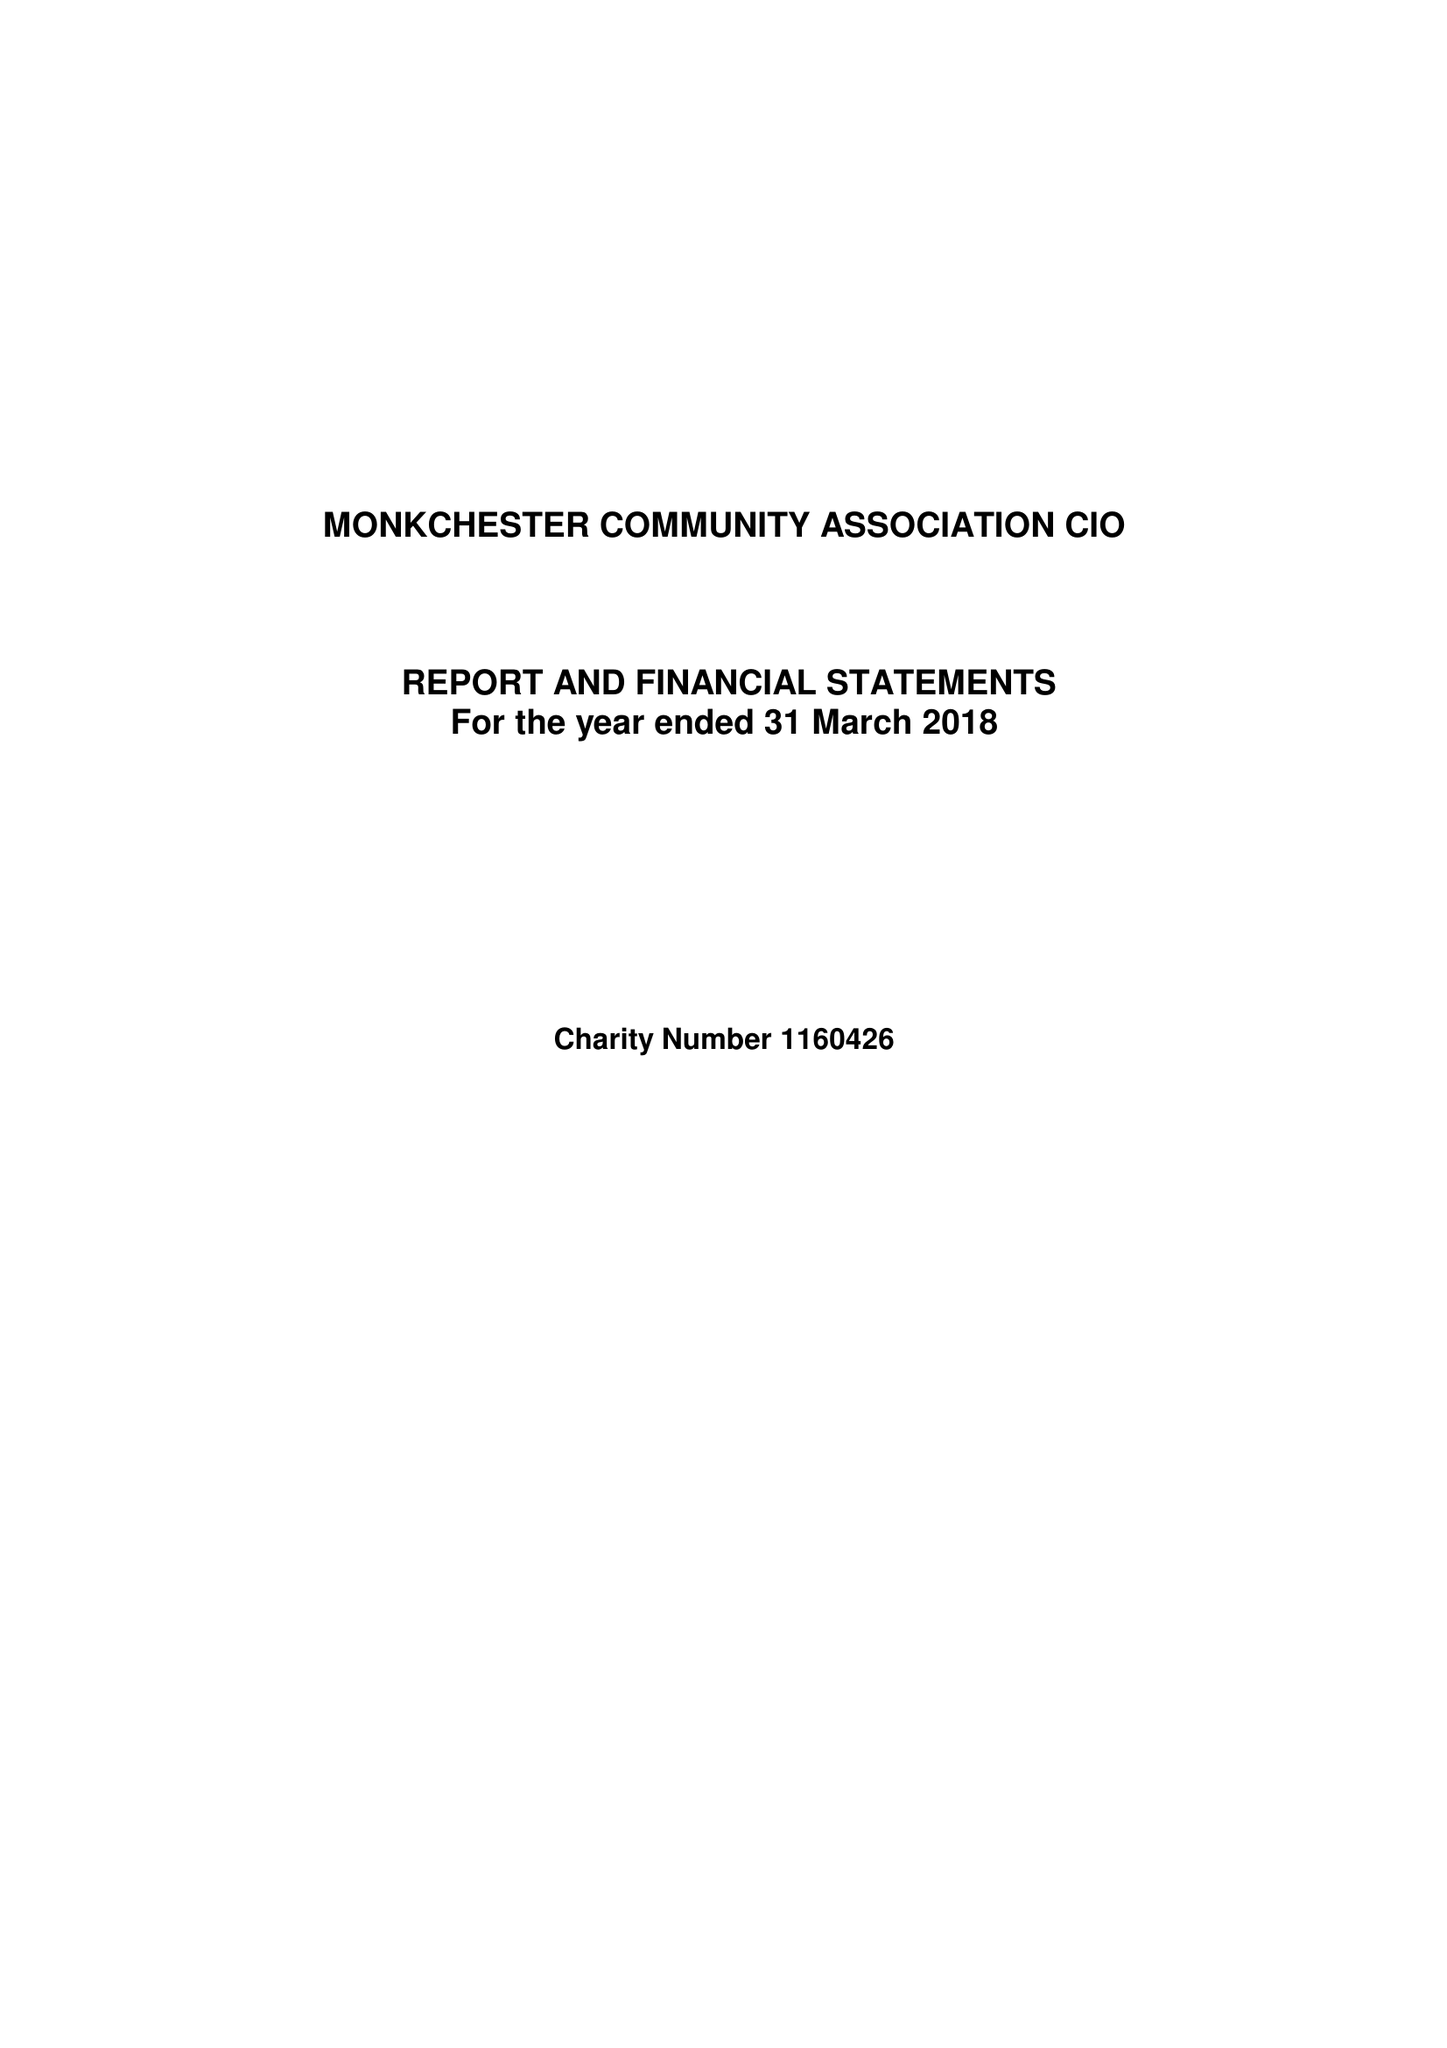What is the value for the address__postcode?
Answer the question using a single word or phrase. NE6 2LJ 